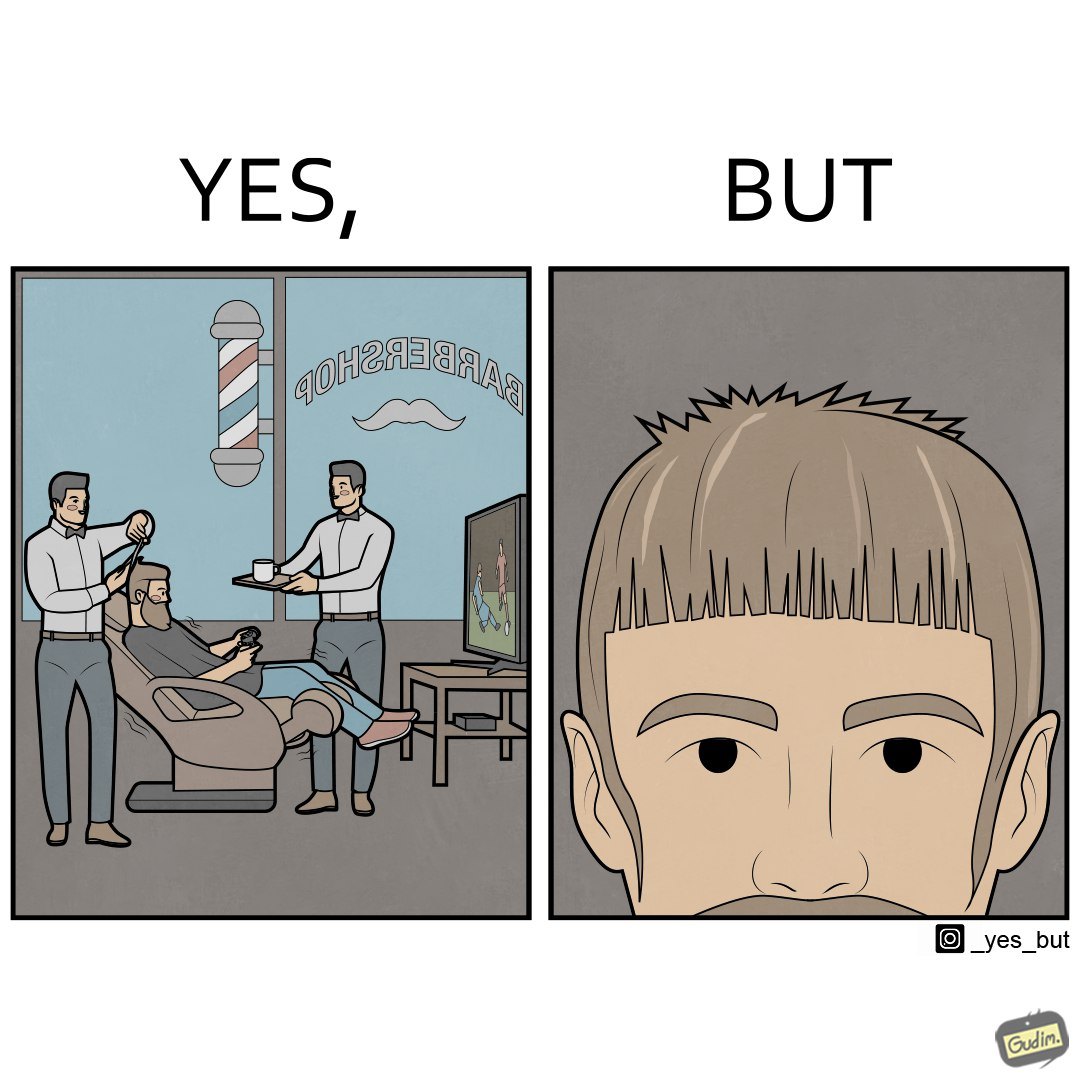Describe the contrast between the left and right parts of this image. In the left part of the image: a person at a men's saloon during his hair cut, playing football game on tv and a person serving him some beverage in cup In the right part of the image: a person with an average looking haircut 